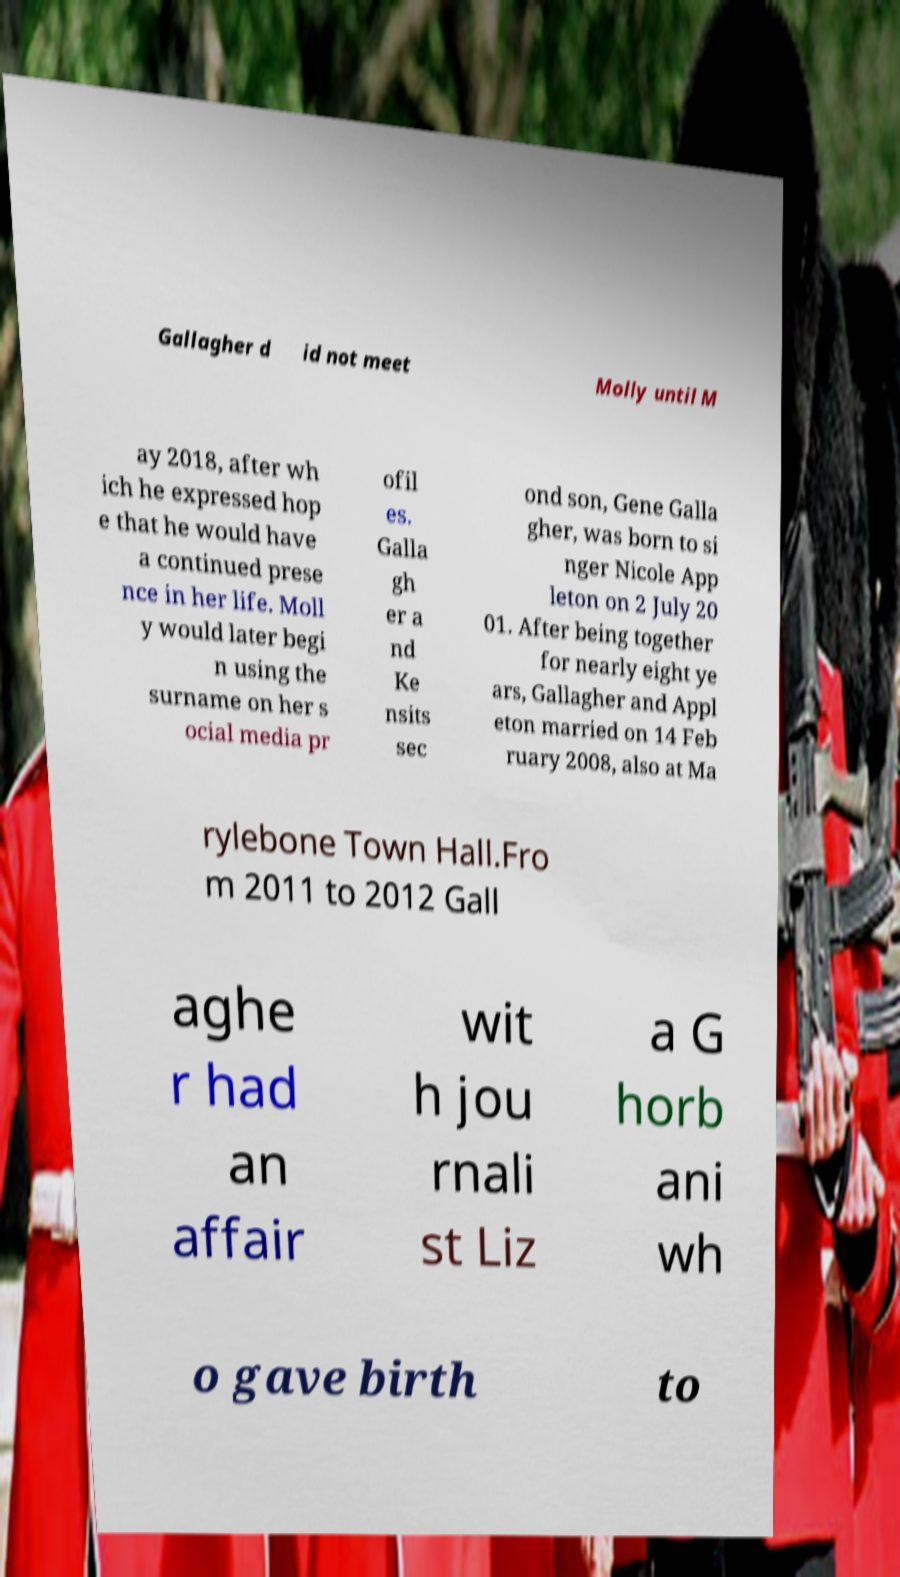For documentation purposes, I need the text within this image transcribed. Could you provide that? Gallagher d id not meet Molly until M ay 2018, after wh ich he expressed hop e that he would have a continued prese nce in her life. Moll y would later begi n using the surname on her s ocial media pr ofil es. Galla gh er a nd Ke nsits sec ond son, Gene Galla gher, was born to si nger Nicole App leton on 2 July 20 01. After being together for nearly eight ye ars, Gallagher and Appl eton married on 14 Feb ruary 2008, also at Ma rylebone Town Hall.Fro m 2011 to 2012 Gall aghe r had an affair wit h jou rnali st Liz a G horb ani wh o gave birth to 